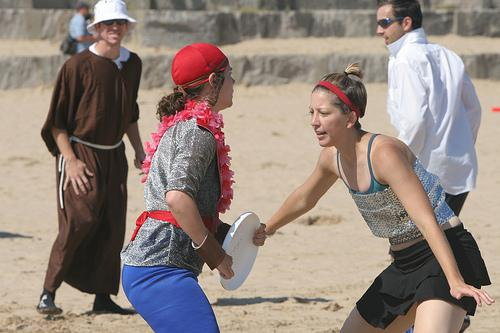Question: what are both men wearing on their faces?
Choices:
A. Mustaches.
B. Sunglasses.
C. Makeup.
D. Masks.
Answer with the letter. Answer: B Question: what are they playing with?
Choices:
A. A football.
B. A soccer ball.
C. A frisbee.
D. A baseball.
Answer with the letter. Answer: C Question: who has the frisby?
Choices:
A. The boy in the center.
B. The woman on the left.
C. The girl on the right.
D. The child on the grass.
Answer with the letter. Answer: B Question: what color is the woman on the left's hat?
Choices:
A. Red.
B. Blue.
C. Black.
D. White.
Answer with the letter. Answer: A Question: where are they?
Choices:
A. The park.
B. The school.
C. The church.
D. The beach.
Answer with the letter. Answer: D 